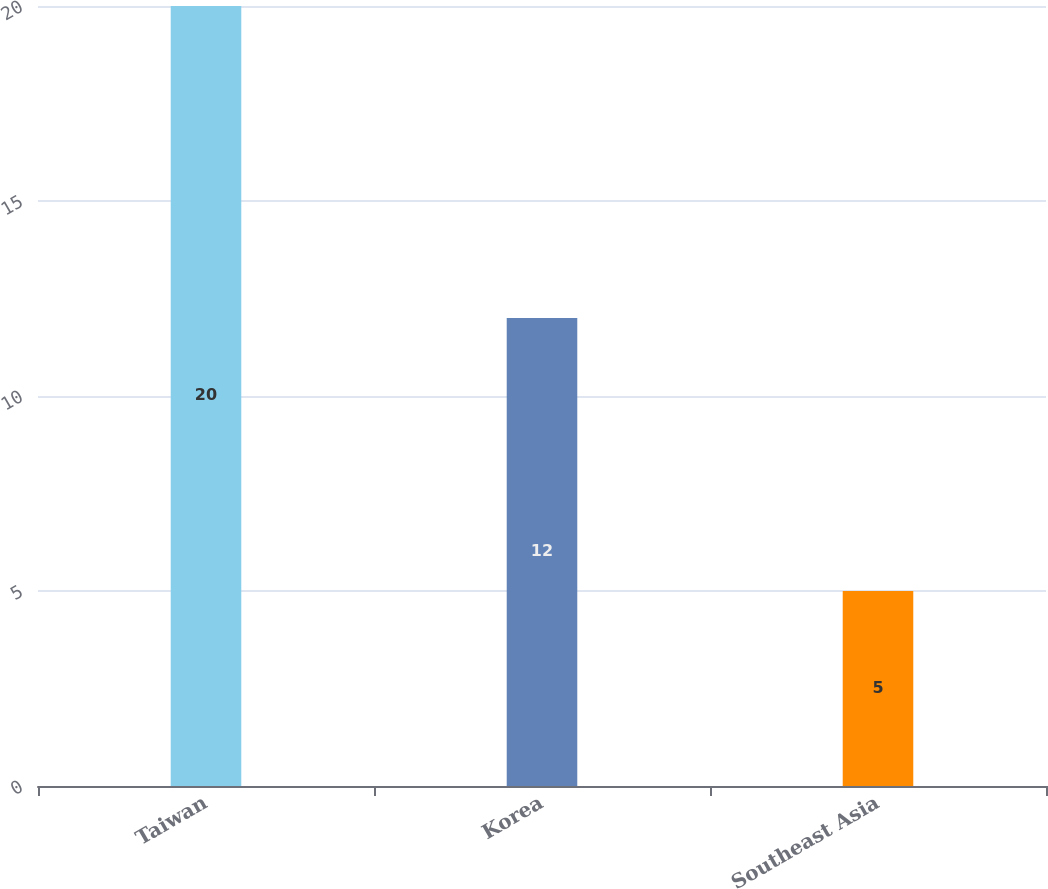Convert chart to OTSL. <chart><loc_0><loc_0><loc_500><loc_500><bar_chart><fcel>Taiwan<fcel>Korea<fcel>Southeast Asia<nl><fcel>20<fcel>12<fcel>5<nl></chart> 